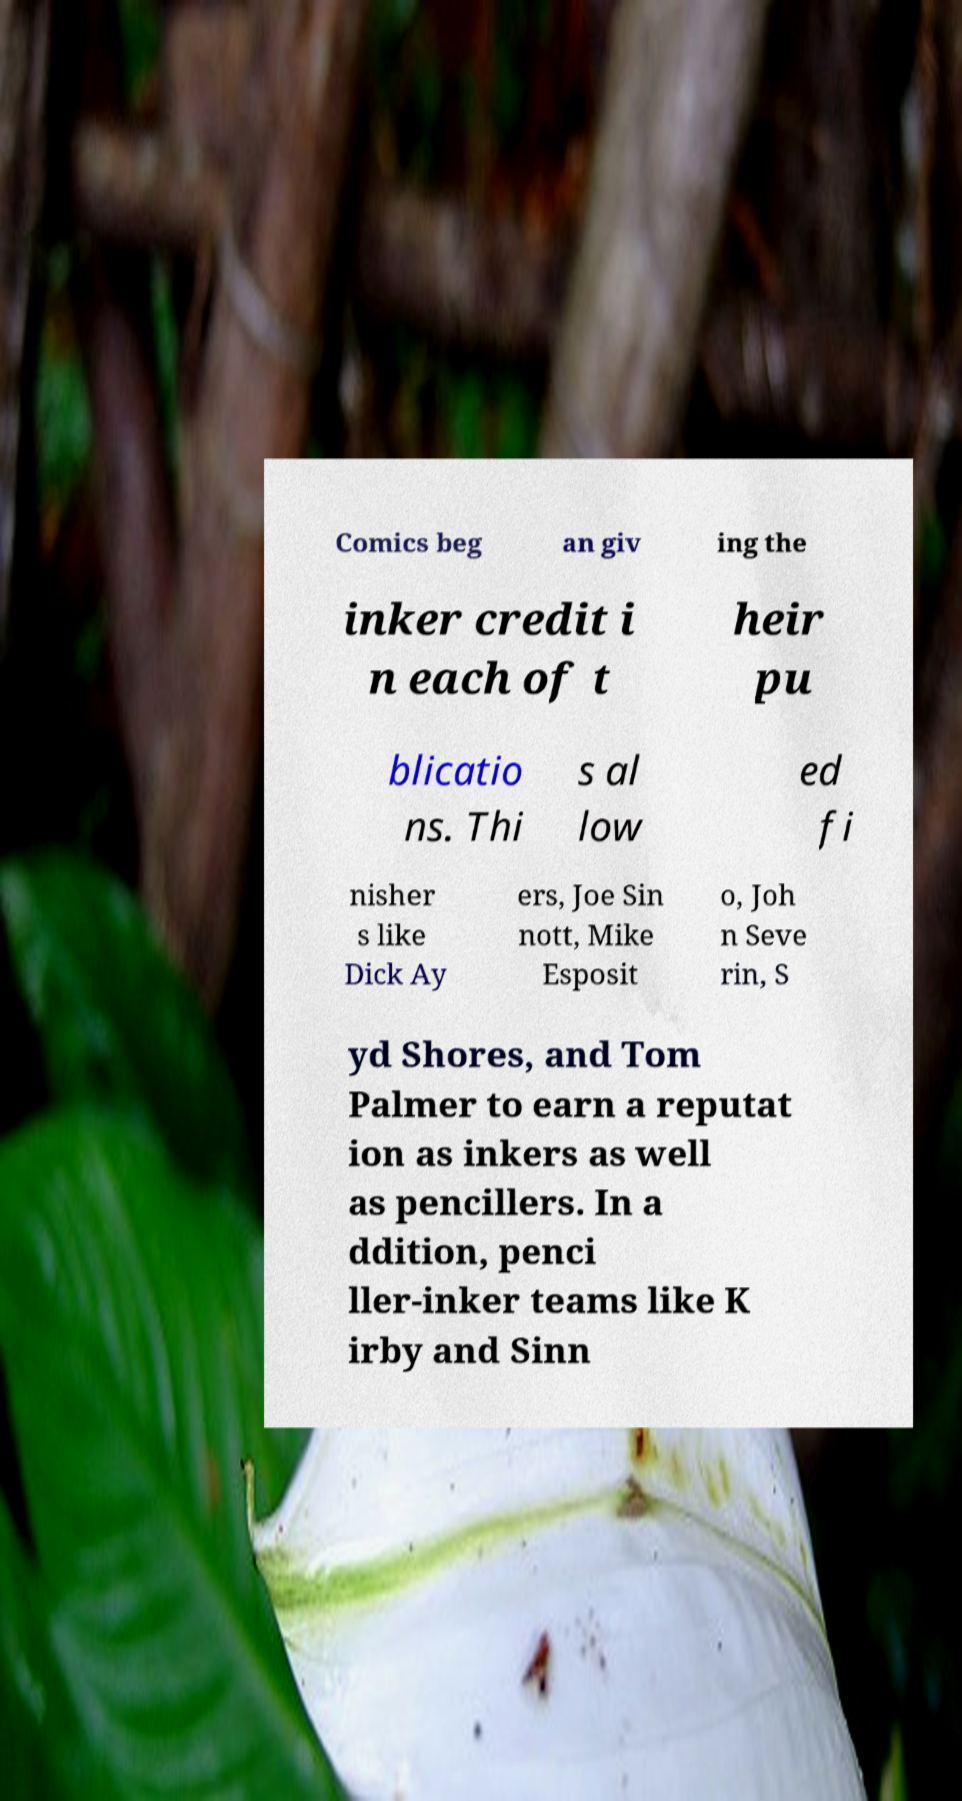Could you assist in decoding the text presented in this image and type it out clearly? Comics beg an giv ing the inker credit i n each of t heir pu blicatio ns. Thi s al low ed fi nisher s like Dick Ay ers, Joe Sin nott, Mike Esposit o, Joh n Seve rin, S yd Shores, and Tom Palmer to earn a reputat ion as inkers as well as pencillers. In a ddition, penci ller-inker teams like K irby and Sinn 